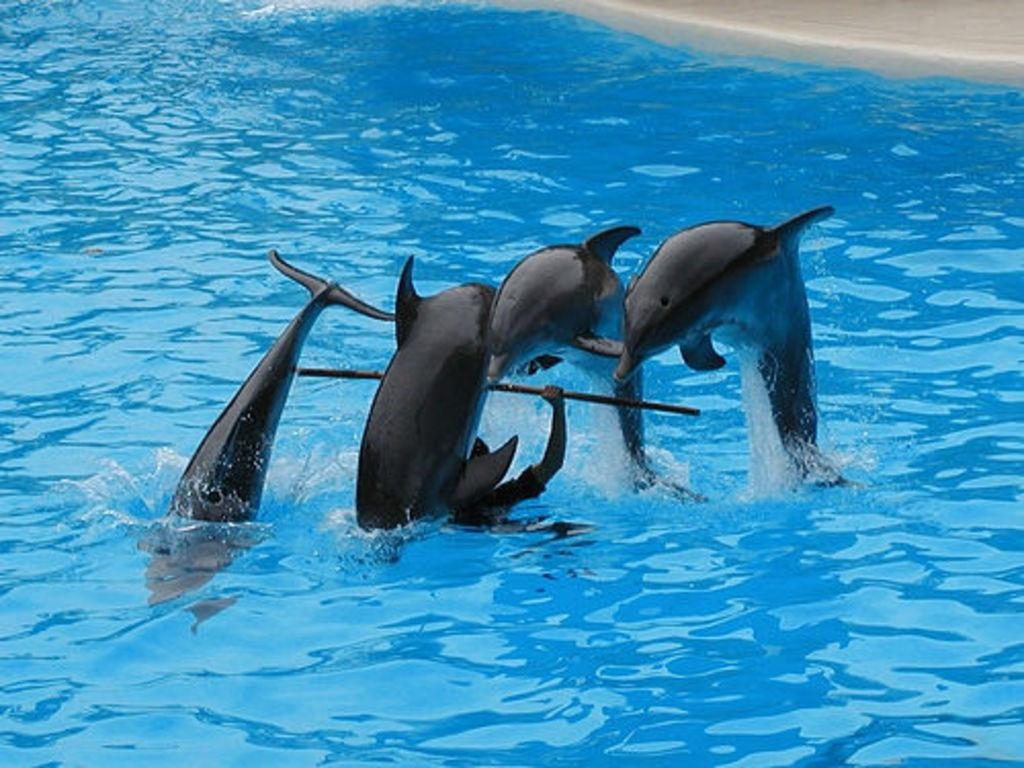Who or what is present in the image? There is a person in the image. What is the person doing in the image? The person is holding an object. What type of animals can be seen in the image? There are dolphins visible in the image. What is the primary setting of the image? There is water visible in the image. What type of chair can be seen in the image? There is no chair present in the image. How many bits are visible in the image? There are no bits present in the image. 